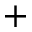<formula> <loc_0><loc_0><loc_500><loc_500>^ { + }</formula> 